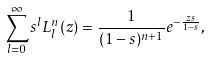<formula> <loc_0><loc_0><loc_500><loc_500>\sum _ { l = 0 } ^ { \infty } s ^ { l } L _ { l } ^ { n } ( z ) = \frac { 1 } { ( 1 - s ) ^ { n + 1 } } e ^ { - \frac { z s } { 1 - s } } ,</formula> 